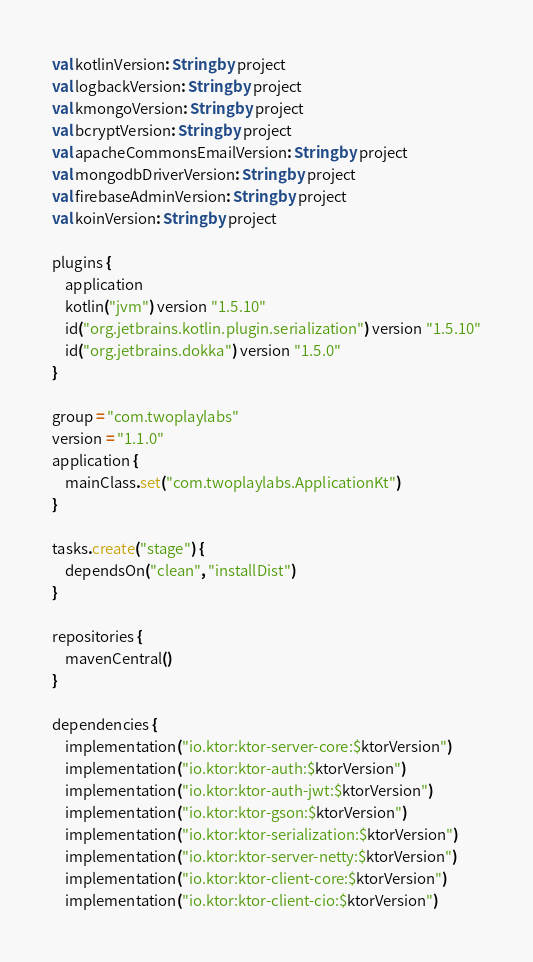<code> <loc_0><loc_0><loc_500><loc_500><_Kotlin_>val kotlinVersion: String by project
val logbackVersion: String by project
val kmongoVersion: String by project
val bcryptVersion: String by project
val apacheCommonsEmailVersion: String by project
val mongodbDriverVersion: String by project
val firebaseAdminVersion: String by project
val koinVersion: String by project

plugins {
    application
    kotlin("jvm") version "1.5.10"
    id("org.jetbrains.kotlin.plugin.serialization") version "1.5.10"
    id("org.jetbrains.dokka") version "1.5.0"
}

group = "com.twoplaylabs"
version = "1.1.0"
application {
    mainClass.set("com.twoplaylabs.ApplicationKt")
}

tasks.create("stage") {
    dependsOn("clean", "installDist")
}

repositories {
    mavenCentral()
}

dependencies {
    implementation("io.ktor:ktor-server-core:$ktorVersion")
    implementation("io.ktor:ktor-auth:$ktorVersion")
    implementation("io.ktor:ktor-auth-jwt:$ktorVersion")
    implementation("io.ktor:ktor-gson:$ktorVersion")
    implementation("io.ktor:ktor-serialization:$ktorVersion")
    implementation("io.ktor:ktor-server-netty:$ktorVersion")
    implementation("io.ktor:ktor-client-core:$ktorVersion")
    implementation("io.ktor:ktor-client-cio:$ktorVersion")</code> 